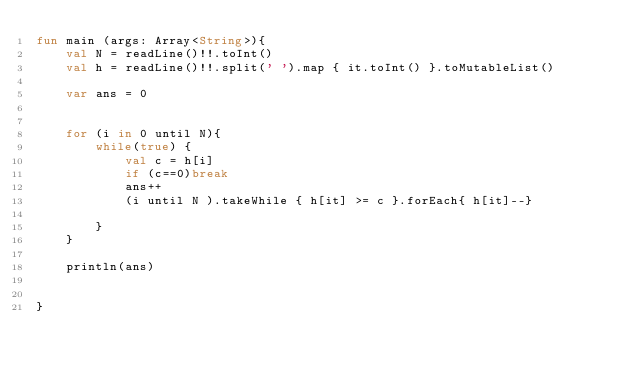<code> <loc_0><loc_0><loc_500><loc_500><_Kotlin_>fun main (args: Array<String>){
    val N = readLine()!!.toInt()
    val h = readLine()!!.split(' ').map { it.toInt() }.toMutableList()

    var ans = 0


    for (i in 0 until N){
        while(true) {
            val c = h[i]
            if (c==0)break
            ans++
            (i until N ).takeWhile { h[it] >= c }.forEach{ h[it]--}

        }
    }

    println(ans)


}</code> 